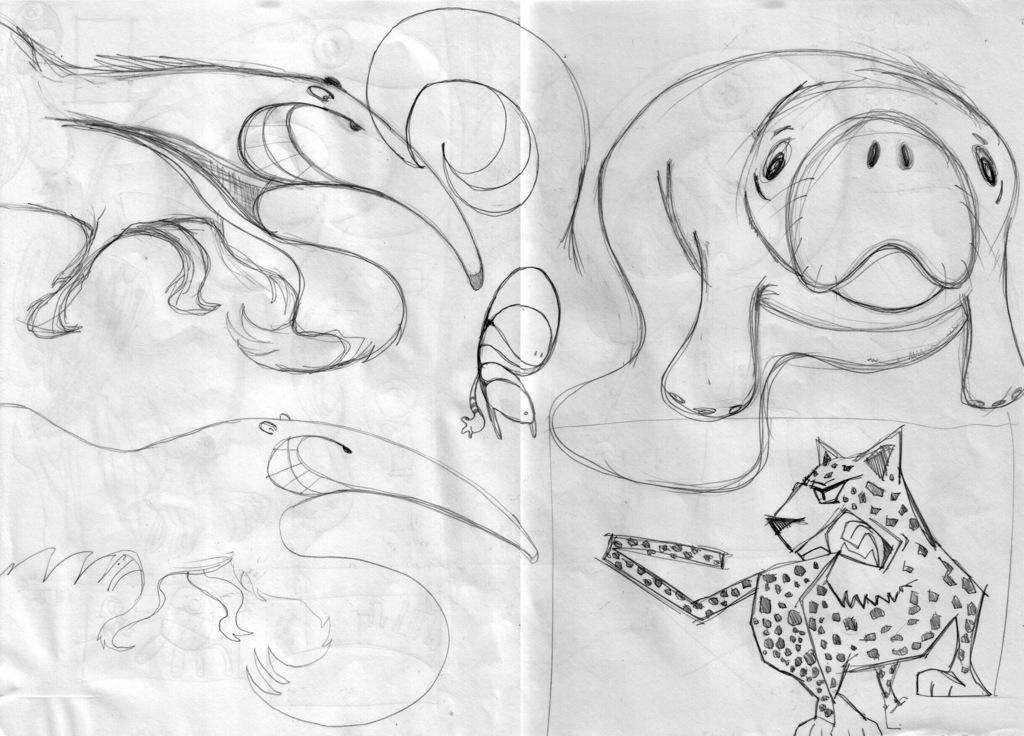What is the main subject in the center of the image? There is a paper in the center of the image. What can be found on the paper? The paper contains drawings of animals. How many hens are depicted in the image? There is no hen present in the image; the paper contains drawings of animals, but no specific animals are mentioned. 